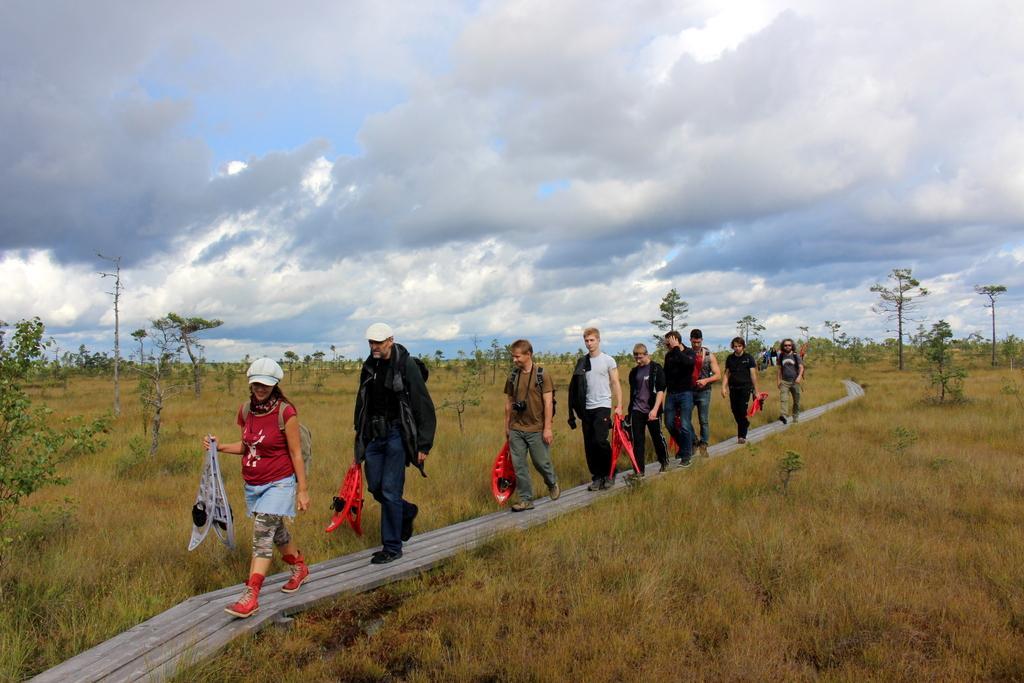Please provide a concise description of this image. This picture is taken from outside of the city. In this image, in the middle, we can see a group of people are walking on the bridge. On the right side, we can see some trees, plants. On the left side, we can see some trees and plants. At the top, we can see a sky which is a bit cloudy, at the bottom, we can see a grass. 